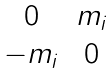Convert formula to latex. <formula><loc_0><loc_0><loc_500><loc_500>\begin{matrix} 0 & m _ { i } \\ - m _ { i } & 0 \end{matrix}</formula> 